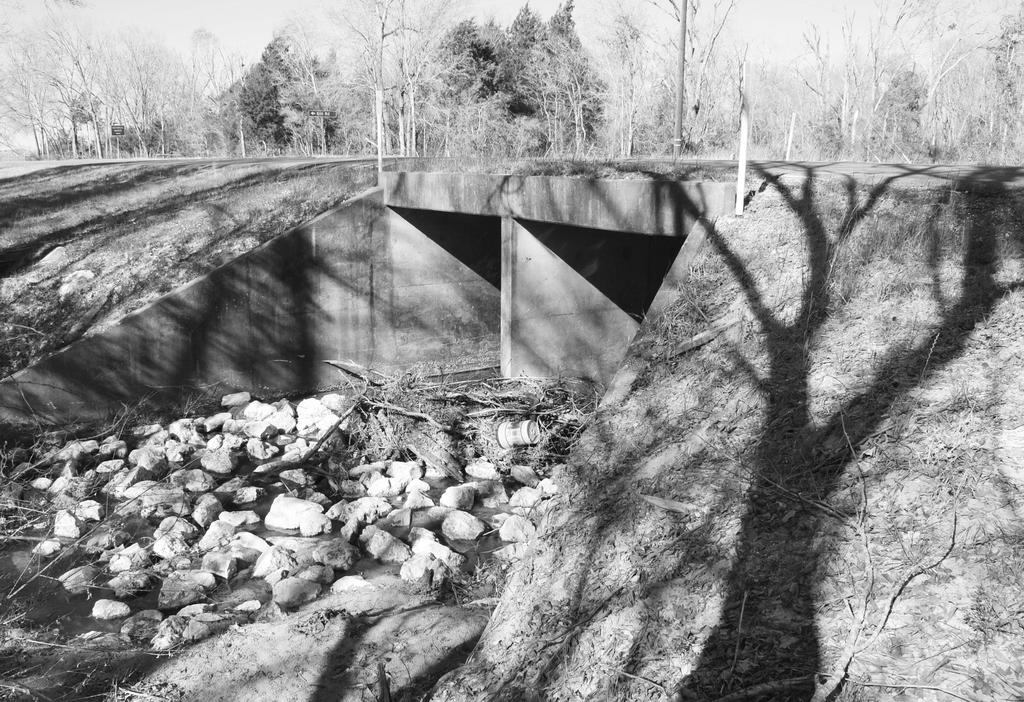What is the color scheme of the image? The image is black and white. What type of natural elements can be seen in the image? There are rocks, branches, and trees in the image. What man-made structure is present in the image? There is a bridge in the image. What part of the natural environment is visible in the image? The sky is visible in the image. What type of cheese is being used to build the bridge in the image? There is no cheese present in the image, and the bridge is not being built in the image. 